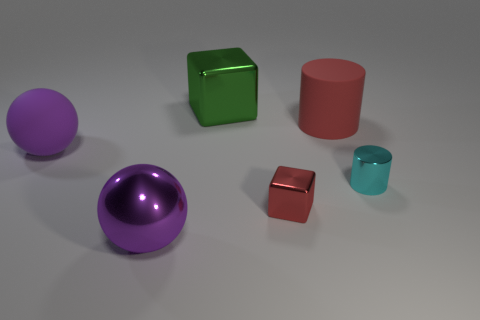Add 3 big blue cylinders. How many objects exist? 9 Subtract all large metallic balls. Subtract all big blue cylinders. How many objects are left? 5 Add 3 small red things. How many small red things are left? 4 Add 5 large blue metallic cubes. How many large blue metallic cubes exist? 5 Subtract 0 purple blocks. How many objects are left? 6 Subtract all cubes. How many objects are left? 4 Subtract all blue cylinders. Subtract all yellow balls. How many cylinders are left? 2 